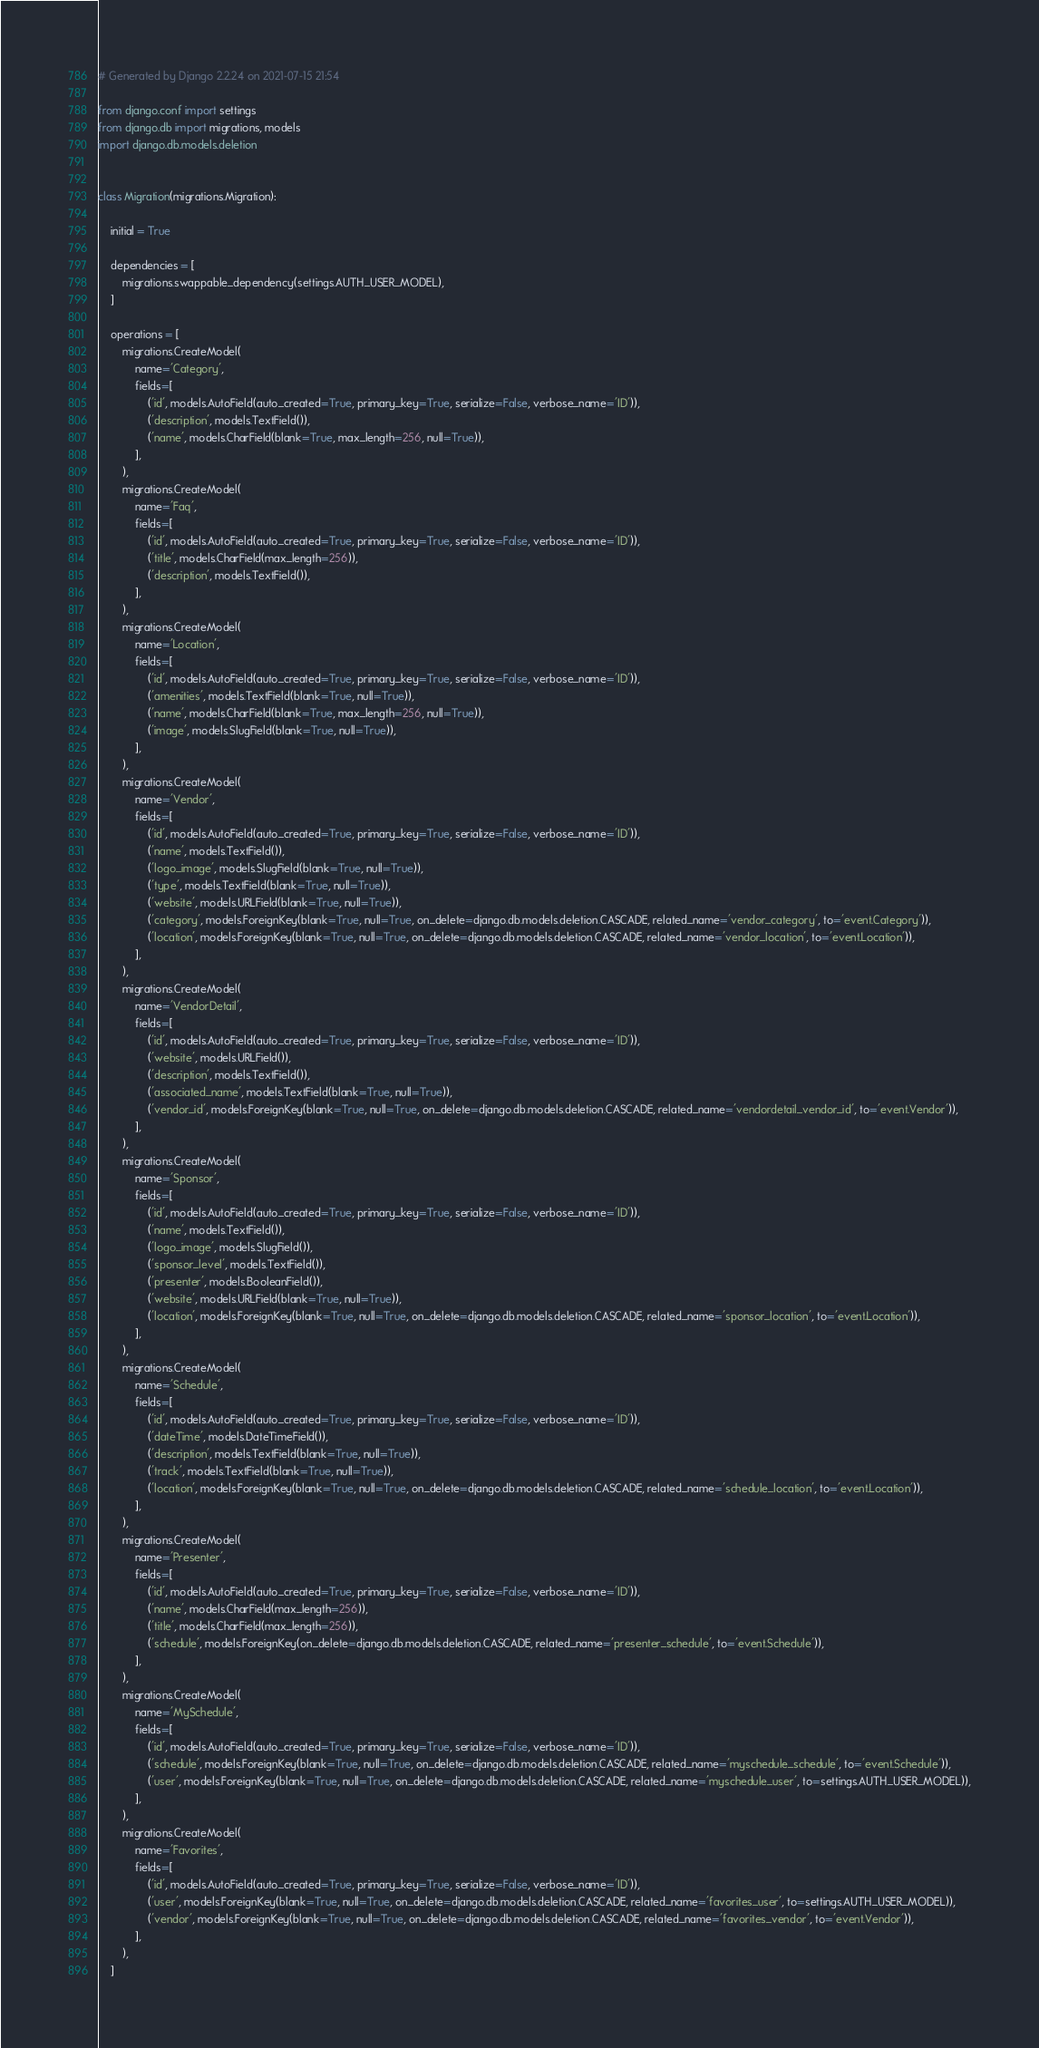<code> <loc_0><loc_0><loc_500><loc_500><_Python_># Generated by Django 2.2.24 on 2021-07-15 21:54

from django.conf import settings
from django.db import migrations, models
import django.db.models.deletion


class Migration(migrations.Migration):

    initial = True

    dependencies = [
        migrations.swappable_dependency(settings.AUTH_USER_MODEL),
    ]

    operations = [
        migrations.CreateModel(
            name='Category',
            fields=[
                ('id', models.AutoField(auto_created=True, primary_key=True, serialize=False, verbose_name='ID')),
                ('description', models.TextField()),
                ('name', models.CharField(blank=True, max_length=256, null=True)),
            ],
        ),
        migrations.CreateModel(
            name='Faq',
            fields=[
                ('id', models.AutoField(auto_created=True, primary_key=True, serialize=False, verbose_name='ID')),
                ('title', models.CharField(max_length=256)),
                ('description', models.TextField()),
            ],
        ),
        migrations.CreateModel(
            name='Location',
            fields=[
                ('id', models.AutoField(auto_created=True, primary_key=True, serialize=False, verbose_name='ID')),
                ('amenities', models.TextField(blank=True, null=True)),
                ('name', models.CharField(blank=True, max_length=256, null=True)),
                ('image', models.SlugField(blank=True, null=True)),
            ],
        ),
        migrations.CreateModel(
            name='Vendor',
            fields=[
                ('id', models.AutoField(auto_created=True, primary_key=True, serialize=False, verbose_name='ID')),
                ('name', models.TextField()),
                ('logo_image', models.SlugField(blank=True, null=True)),
                ('type', models.TextField(blank=True, null=True)),
                ('website', models.URLField(blank=True, null=True)),
                ('category', models.ForeignKey(blank=True, null=True, on_delete=django.db.models.deletion.CASCADE, related_name='vendor_category', to='event.Category')),
                ('location', models.ForeignKey(blank=True, null=True, on_delete=django.db.models.deletion.CASCADE, related_name='vendor_location', to='event.Location')),
            ],
        ),
        migrations.CreateModel(
            name='VendorDetail',
            fields=[
                ('id', models.AutoField(auto_created=True, primary_key=True, serialize=False, verbose_name='ID')),
                ('website', models.URLField()),
                ('description', models.TextField()),
                ('associated_name', models.TextField(blank=True, null=True)),
                ('vendor_id', models.ForeignKey(blank=True, null=True, on_delete=django.db.models.deletion.CASCADE, related_name='vendordetail_vendor_id', to='event.Vendor')),
            ],
        ),
        migrations.CreateModel(
            name='Sponsor',
            fields=[
                ('id', models.AutoField(auto_created=True, primary_key=True, serialize=False, verbose_name='ID')),
                ('name', models.TextField()),
                ('logo_image', models.SlugField()),
                ('sponsor_level', models.TextField()),
                ('presenter', models.BooleanField()),
                ('website', models.URLField(blank=True, null=True)),
                ('location', models.ForeignKey(blank=True, null=True, on_delete=django.db.models.deletion.CASCADE, related_name='sponsor_location', to='event.Location')),
            ],
        ),
        migrations.CreateModel(
            name='Schedule',
            fields=[
                ('id', models.AutoField(auto_created=True, primary_key=True, serialize=False, verbose_name='ID')),
                ('dateTime', models.DateTimeField()),
                ('description', models.TextField(blank=True, null=True)),
                ('track', models.TextField(blank=True, null=True)),
                ('location', models.ForeignKey(blank=True, null=True, on_delete=django.db.models.deletion.CASCADE, related_name='schedule_location', to='event.Location')),
            ],
        ),
        migrations.CreateModel(
            name='Presenter',
            fields=[
                ('id', models.AutoField(auto_created=True, primary_key=True, serialize=False, verbose_name='ID')),
                ('name', models.CharField(max_length=256)),
                ('title', models.CharField(max_length=256)),
                ('schedule', models.ForeignKey(on_delete=django.db.models.deletion.CASCADE, related_name='presenter_schedule', to='event.Schedule')),
            ],
        ),
        migrations.CreateModel(
            name='MySchedule',
            fields=[
                ('id', models.AutoField(auto_created=True, primary_key=True, serialize=False, verbose_name='ID')),
                ('schedule', models.ForeignKey(blank=True, null=True, on_delete=django.db.models.deletion.CASCADE, related_name='myschedule_schedule', to='event.Schedule')),
                ('user', models.ForeignKey(blank=True, null=True, on_delete=django.db.models.deletion.CASCADE, related_name='myschedule_user', to=settings.AUTH_USER_MODEL)),
            ],
        ),
        migrations.CreateModel(
            name='Favorites',
            fields=[
                ('id', models.AutoField(auto_created=True, primary_key=True, serialize=False, verbose_name='ID')),
                ('user', models.ForeignKey(blank=True, null=True, on_delete=django.db.models.deletion.CASCADE, related_name='favorites_user', to=settings.AUTH_USER_MODEL)),
                ('vendor', models.ForeignKey(blank=True, null=True, on_delete=django.db.models.deletion.CASCADE, related_name='favorites_vendor', to='event.Vendor')),
            ],
        ),
    ]
</code> 